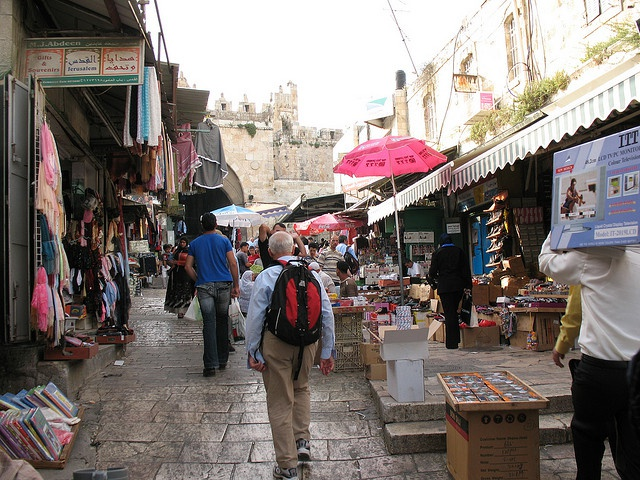Describe the objects in this image and their specific colors. I can see people in gray, black, and darkgray tones, people in gray, black, maroon, and darkgray tones, people in gray, black, navy, and maroon tones, backpack in gray, black, brown, and maroon tones, and umbrella in gray, salmon, lightpink, and brown tones in this image. 